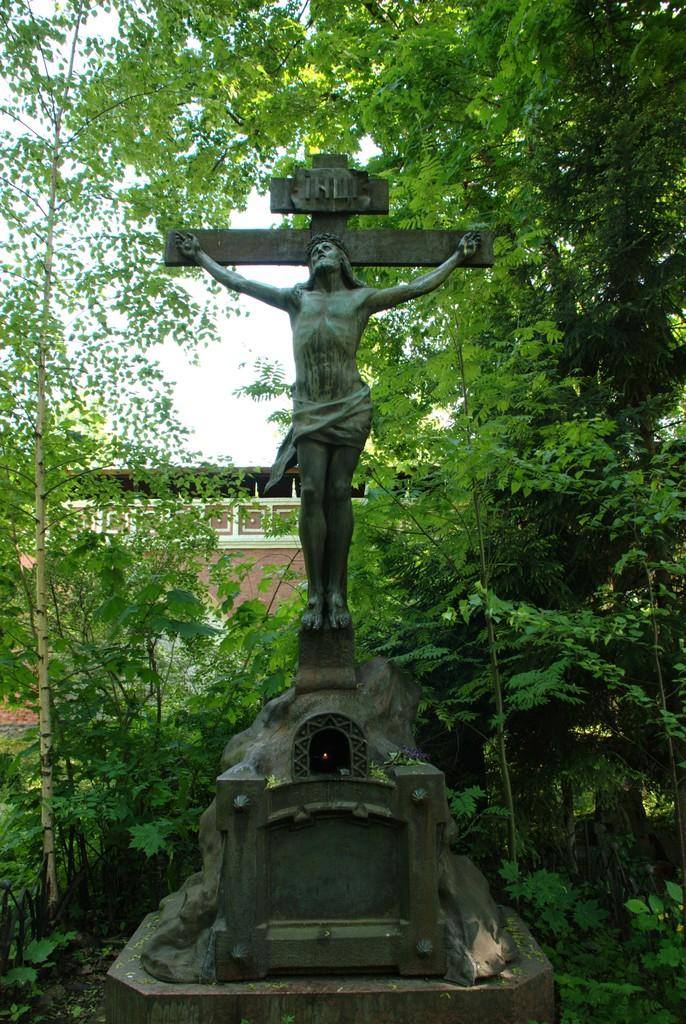What is the main subject of the image? There is a sculpture of a person in the image. What symbol can be seen on the sculpture? The sculpture has a holy cross symbol. Where is the sculpture located? The sculpture is on a rock. What type of natural environment is visible in the image? There are trees in the image. What can be seen in the background of the image? There is a building and the sky visible in the background of the image. What type of apparel is the sculpture wearing in the image? The sculpture is not a real person and does not wear apparel; it is a static sculpture made of a material like stone or metal. What angle is the sculpture positioned at in the image? The angle of the sculpture cannot be determined from the image alone, as it depends on the perspective of the person taking the photo. 